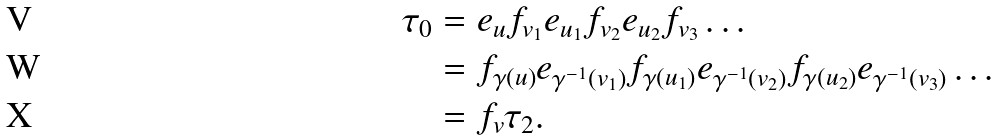Convert formula to latex. <formula><loc_0><loc_0><loc_500><loc_500>\tau _ { 0 } & = e _ { u } f _ { v _ { 1 } } e _ { u _ { 1 } } f _ { v _ { 2 } } e _ { u _ { 2 } } f _ { v _ { 3 } } \dots \\ & = f _ { \gamma ( u ) } e _ { \gamma ^ { - 1 } ( v _ { 1 } ) } f _ { \gamma ( u _ { 1 } ) } e _ { \gamma ^ { - 1 } ( v _ { 2 } ) } f _ { \gamma ( u _ { 2 } ) } e _ { \gamma ^ { - 1 } ( v _ { 3 } ) } \dots \\ & = f _ { v } \tau _ { 2 } .</formula> 